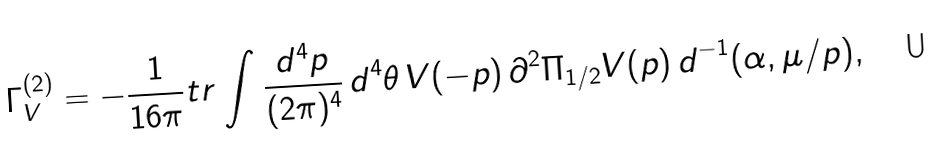<formula> <loc_0><loc_0><loc_500><loc_500>\Gamma ^ { ( 2 ) } _ { V } = - \frac { 1 } { 1 6 \pi } t r \int \frac { d ^ { 4 } p } { ( 2 \pi ) ^ { 4 } } \, d ^ { 4 } \theta \, { V } ( - p ) \, \partial ^ { 2 } \Pi _ { 1 / 2 } { V } ( p ) \, d ^ { - 1 } ( \alpha , \mu / p ) ,</formula> 